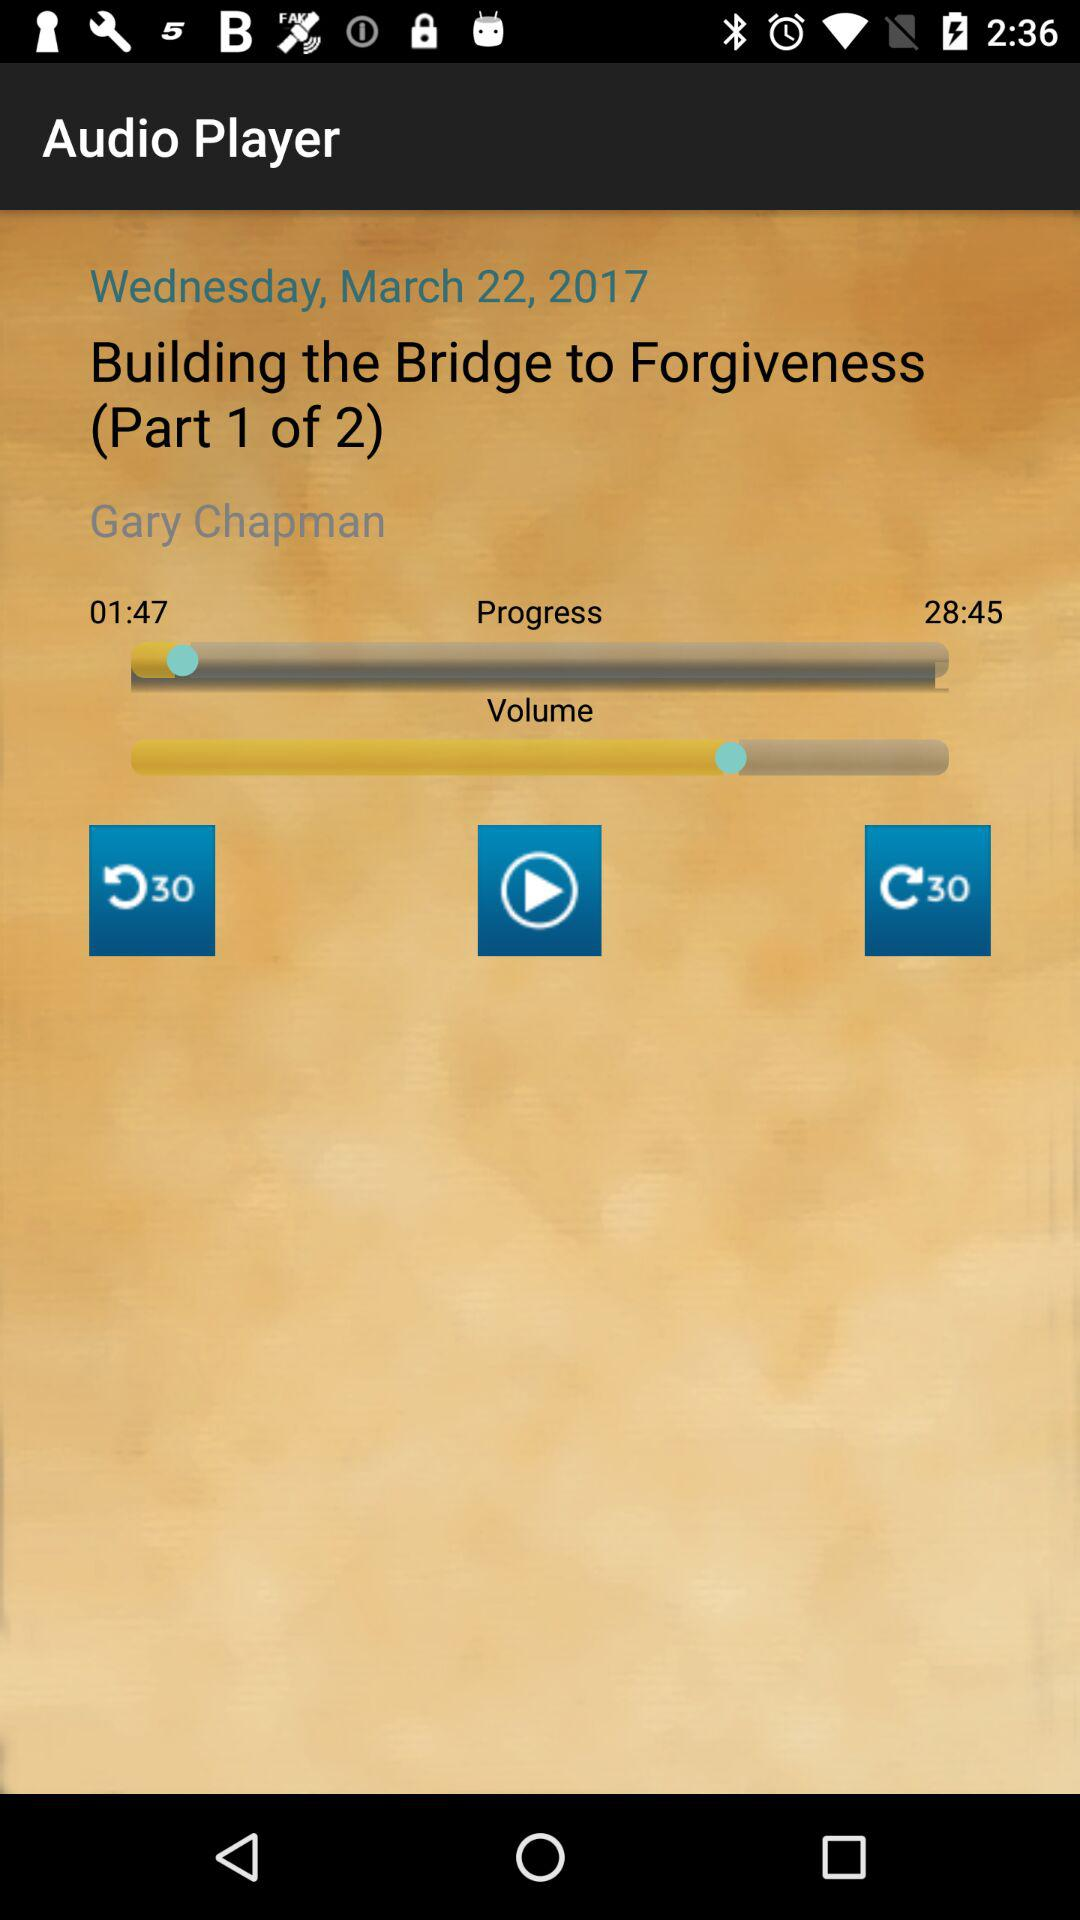What is the day? The day is Wednesday. 